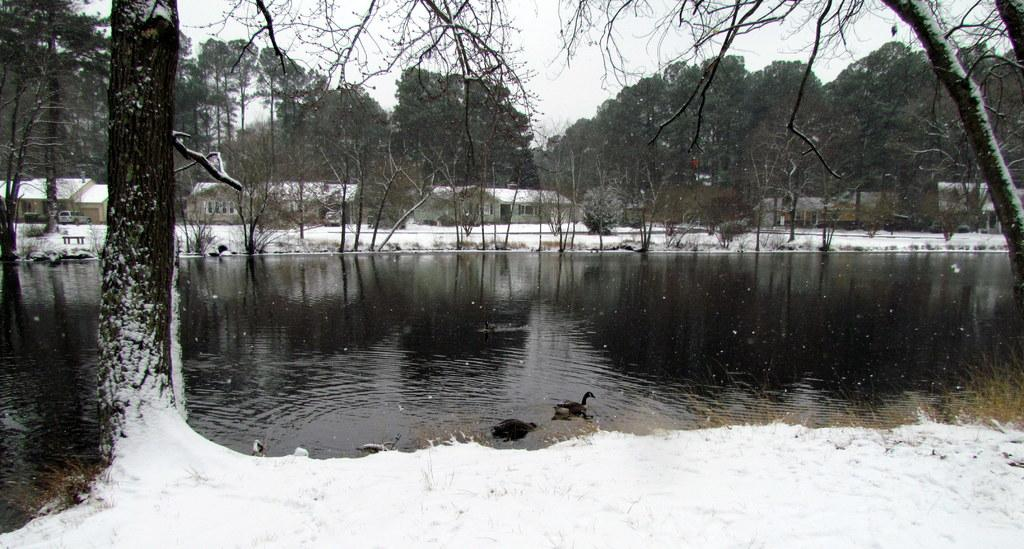What type of animals can be seen in the water in the image? There are birds in the water in the image. What type of weather is depicted in the image? There is snow visible in the image, indicating cold weather. What type of vegetation is present in the image? There is grass visible in the image. What type of natural scenery is visible in the image? There are trees in the image. What part of the natural environment is visible in the image? The sky is visible in the image. What type of man-made structure is present in the image? There is a vehicle in the image. What type of outdoor furniture is present in the image? There is a bench in the image. What type of residential structure is present in the image? There is a house in the image. What type of addition problem can be solved using the numbers on the house in the image? There is no addition problem present in the image, nor are there any numbers visible on the house. 